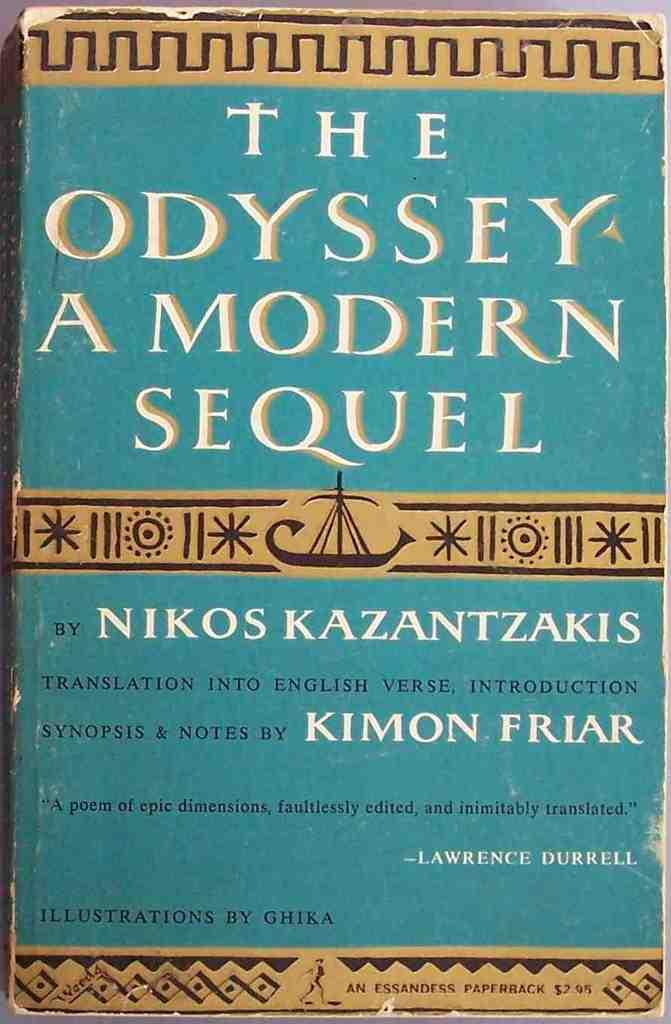<image>
Create a compact narrative representing the image presented. A book titled The Odyssey A Modern Sequel written by Nikos Kazantzakis. 